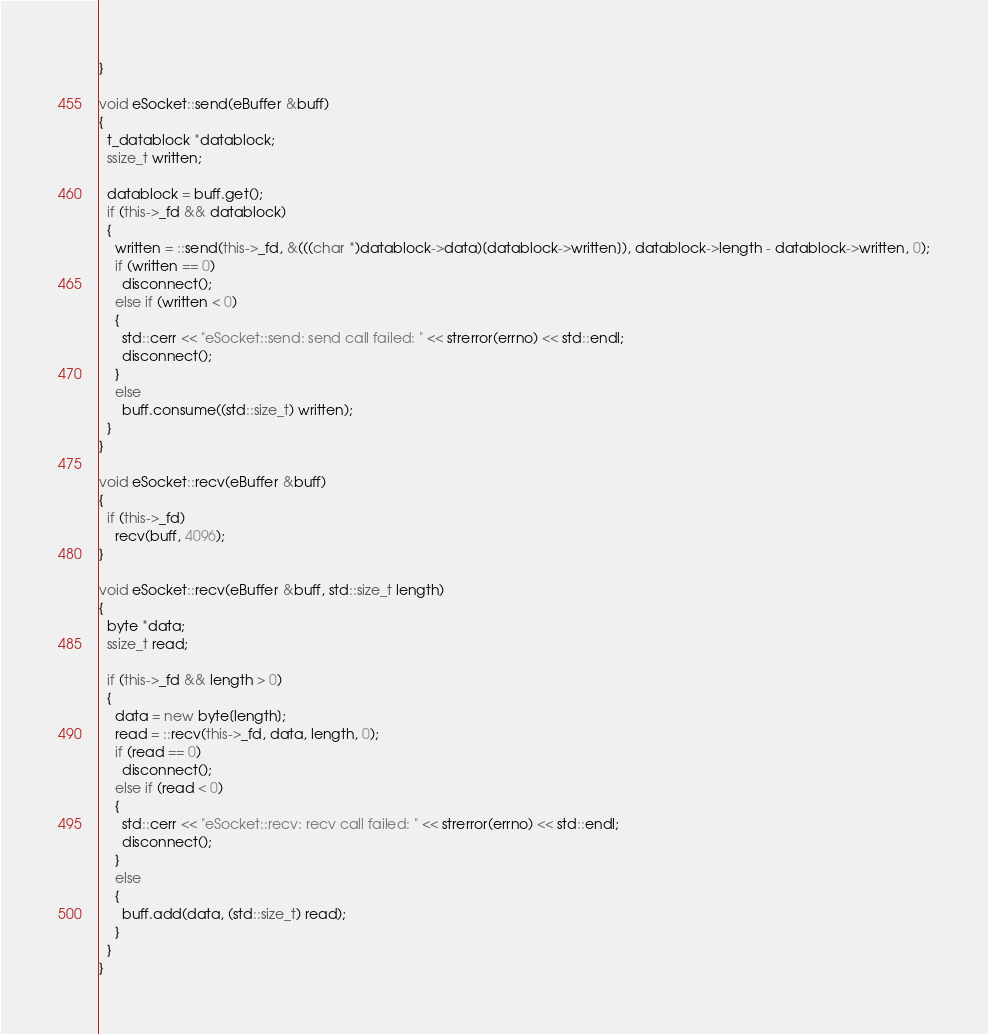<code> <loc_0><loc_0><loc_500><loc_500><_C++_>}

void eSocket::send(eBuffer &buff)
{
  t_datablock *datablock;
  ssize_t written;

  datablock = buff.get();
  if (this->_fd && datablock)
  {
    written = ::send(this->_fd, &(((char *)datablock->data)[datablock->written]), datablock->length - datablock->written, 0);
    if (written == 0)
      disconnect();
    else if (written < 0)
    {
      std::cerr << "eSocket::send: send call failed: " << strerror(errno) << std::endl;
      disconnect();
    }
    else
      buff.consume((std::size_t) written);
  }
}

void eSocket::recv(eBuffer &buff)
{
  if (this->_fd)
    recv(buff, 4096);
}

void eSocket::recv(eBuffer &buff, std::size_t length)
{
  byte *data;
  ssize_t read;

  if (this->_fd && length > 0)
  {
    data = new byte[length];
    read = ::recv(this->_fd, data, length, 0);
    if (read == 0)
      disconnect();
    else if (read < 0)
    {
      std::cerr << "eSocket::recv: recv call failed: " << strerror(errno) << std::endl;
      disconnect();
    }
    else
    {
      buff.add(data, (std::size_t) read);
    }
  }
}
</code> 